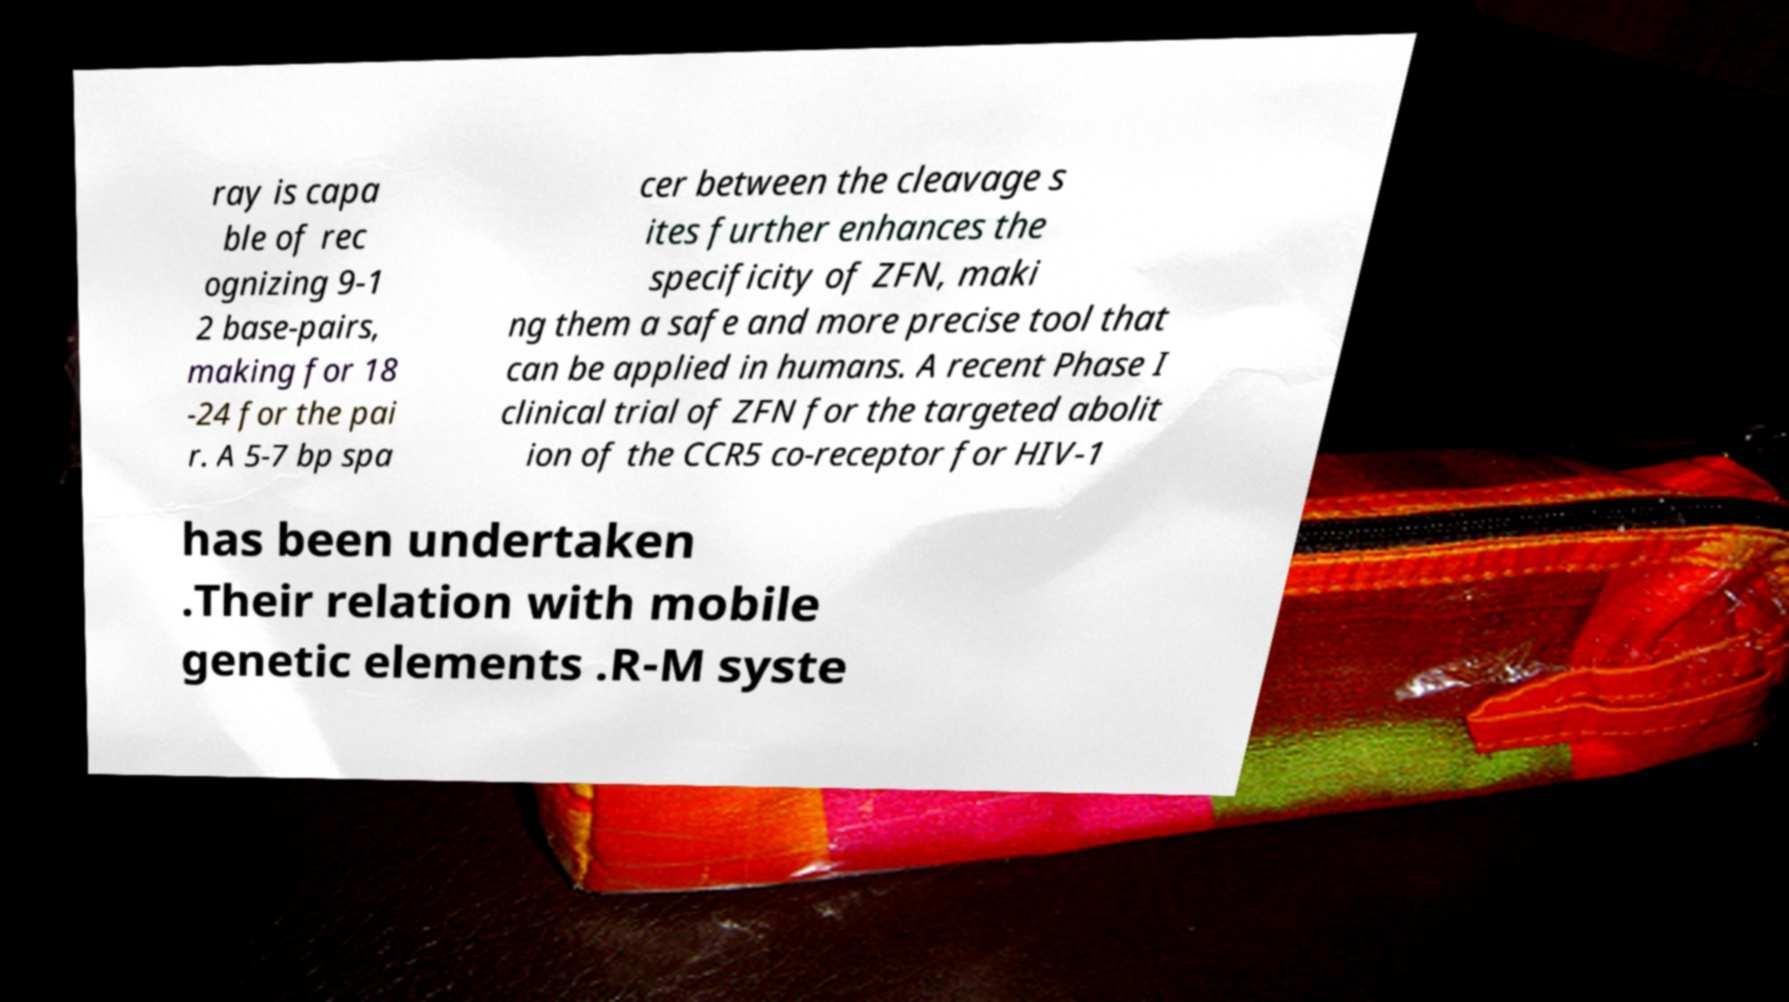Could you assist in decoding the text presented in this image and type it out clearly? ray is capa ble of rec ognizing 9-1 2 base-pairs, making for 18 -24 for the pai r. A 5-7 bp spa cer between the cleavage s ites further enhances the specificity of ZFN, maki ng them a safe and more precise tool that can be applied in humans. A recent Phase I clinical trial of ZFN for the targeted abolit ion of the CCR5 co-receptor for HIV-1 has been undertaken .Their relation with mobile genetic elements .R-M syste 